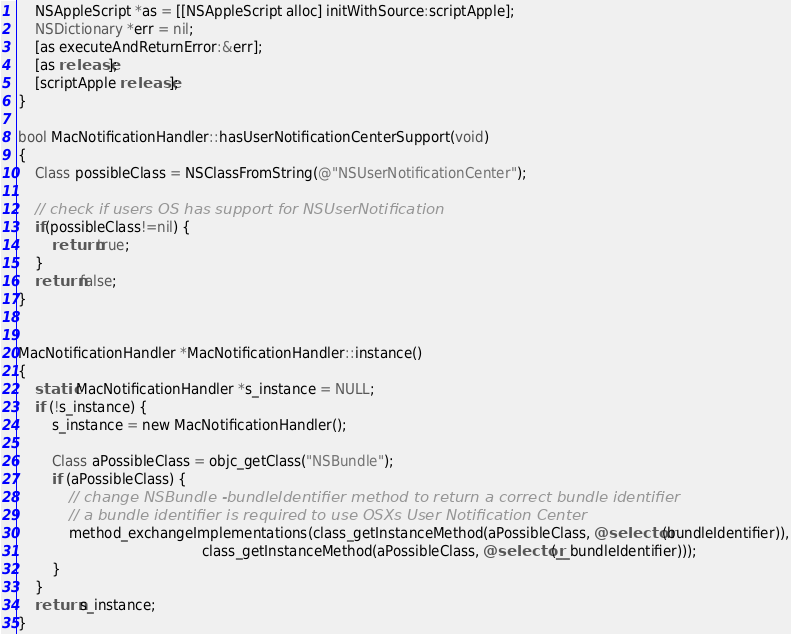Convert code to text. <code><loc_0><loc_0><loc_500><loc_500><_ObjectiveC_>    NSAppleScript *as = [[NSAppleScript alloc] initWithSource:scriptApple];
    NSDictionary *err = nil;
    [as executeAndReturnError:&err];
    [as release];
    [scriptApple release];
}

bool MacNotificationHandler::hasUserNotificationCenterSupport(void)
{
    Class possibleClass = NSClassFromString(@"NSUserNotificationCenter");

    // check if users OS has support for NSUserNotification
    if(possibleClass!=nil) {
        return true;
    }
    return false;
}


MacNotificationHandler *MacNotificationHandler::instance()
{
    static MacNotificationHandler *s_instance = NULL;
    if (!s_instance) {
        s_instance = new MacNotificationHandler();
        
        Class aPossibleClass = objc_getClass("NSBundle");
        if (aPossibleClass) {
            // change NSBundle -bundleIdentifier method to return a correct bundle identifier
            // a bundle identifier is required to use OSXs User Notification Center
            method_exchangeImplementations(class_getInstanceMethod(aPossibleClass, @selector(bundleIdentifier)),
                                           class_getInstanceMethod(aPossibleClass, @selector(__bundleIdentifier)));
        }
    }
    return s_instance;
}
</code> 